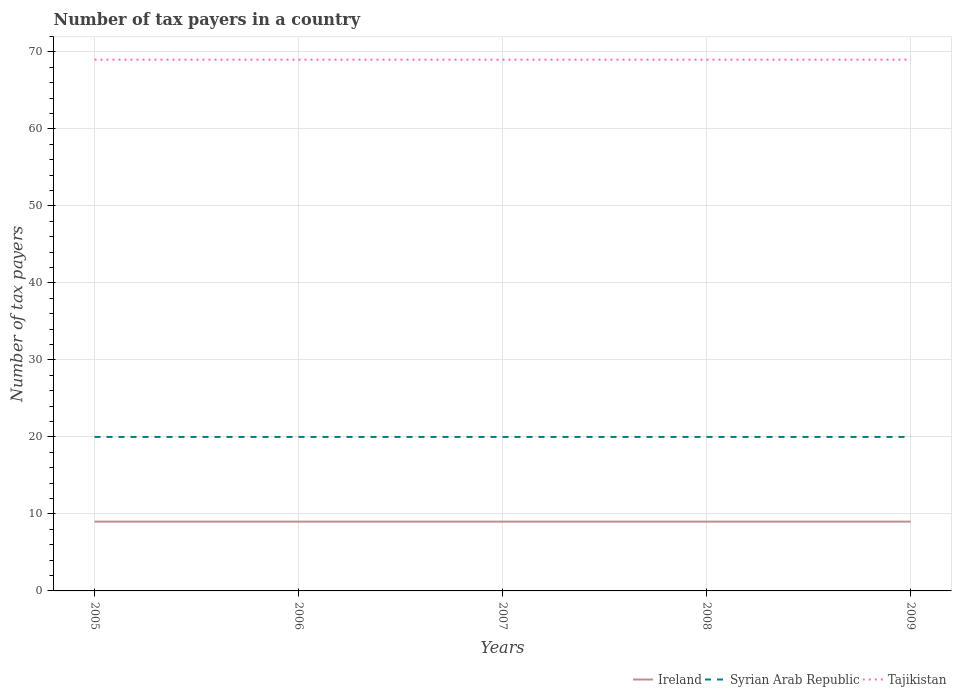How many different coloured lines are there?
Provide a short and direct response. 3. Across all years, what is the maximum number of tax payers in in Ireland?
Your answer should be compact. 9. What is the difference between the highest and the second highest number of tax payers in in Syrian Arab Republic?
Give a very brief answer. 0. What is the difference between the highest and the lowest number of tax payers in in Ireland?
Make the answer very short. 0. What is the difference between two consecutive major ticks on the Y-axis?
Keep it short and to the point. 10. Does the graph contain any zero values?
Provide a short and direct response. No. How many legend labels are there?
Make the answer very short. 3. How are the legend labels stacked?
Provide a short and direct response. Horizontal. What is the title of the graph?
Provide a short and direct response. Number of tax payers in a country. What is the label or title of the Y-axis?
Ensure brevity in your answer.  Number of tax payers. What is the Number of tax payers in Ireland in 2005?
Offer a very short reply. 9. What is the Number of tax payers of Syrian Arab Republic in 2005?
Give a very brief answer. 20. What is the Number of tax payers in Tajikistan in 2005?
Provide a short and direct response. 69. What is the Number of tax payers in Tajikistan in 2006?
Offer a very short reply. 69. What is the Number of tax payers in Ireland in 2007?
Give a very brief answer. 9. What is the Number of tax payers in Tajikistan in 2007?
Offer a very short reply. 69. What is the Number of tax payers of Syrian Arab Republic in 2008?
Provide a short and direct response. 20. What is the Number of tax payers of Tajikistan in 2008?
Offer a very short reply. 69. What is the Number of tax payers in Ireland in 2009?
Your answer should be very brief. 9. What is the Number of tax payers of Syrian Arab Republic in 2009?
Your response must be concise. 20. What is the Number of tax payers of Tajikistan in 2009?
Provide a succinct answer. 69. What is the total Number of tax payers of Tajikistan in the graph?
Your answer should be compact. 345. What is the difference between the Number of tax payers in Ireland in 2005 and that in 2006?
Offer a very short reply. 0. What is the difference between the Number of tax payers in Tajikistan in 2005 and that in 2006?
Make the answer very short. 0. What is the difference between the Number of tax payers of Tajikistan in 2005 and that in 2007?
Offer a very short reply. 0. What is the difference between the Number of tax payers in Syrian Arab Republic in 2005 and that in 2008?
Give a very brief answer. 0. What is the difference between the Number of tax payers in Tajikistan in 2005 and that in 2008?
Your answer should be very brief. 0. What is the difference between the Number of tax payers in Ireland in 2006 and that in 2007?
Give a very brief answer. 0. What is the difference between the Number of tax payers in Ireland in 2006 and that in 2008?
Your answer should be compact. 0. What is the difference between the Number of tax payers in Tajikistan in 2006 and that in 2008?
Your answer should be very brief. 0. What is the difference between the Number of tax payers in Ireland in 2006 and that in 2009?
Keep it short and to the point. 0. What is the difference between the Number of tax payers in Syrian Arab Republic in 2006 and that in 2009?
Offer a very short reply. 0. What is the difference between the Number of tax payers in Ireland in 2007 and that in 2008?
Your answer should be compact. 0. What is the difference between the Number of tax payers of Syrian Arab Republic in 2007 and that in 2008?
Keep it short and to the point. 0. What is the difference between the Number of tax payers of Tajikistan in 2007 and that in 2008?
Your answer should be very brief. 0. What is the difference between the Number of tax payers in Ireland in 2007 and that in 2009?
Offer a terse response. 0. What is the difference between the Number of tax payers of Syrian Arab Republic in 2007 and that in 2009?
Your response must be concise. 0. What is the difference between the Number of tax payers in Ireland in 2008 and that in 2009?
Offer a very short reply. 0. What is the difference between the Number of tax payers in Syrian Arab Republic in 2008 and that in 2009?
Your answer should be very brief. 0. What is the difference between the Number of tax payers in Tajikistan in 2008 and that in 2009?
Your answer should be compact. 0. What is the difference between the Number of tax payers in Ireland in 2005 and the Number of tax payers in Tajikistan in 2006?
Provide a succinct answer. -60. What is the difference between the Number of tax payers in Syrian Arab Republic in 2005 and the Number of tax payers in Tajikistan in 2006?
Give a very brief answer. -49. What is the difference between the Number of tax payers of Ireland in 2005 and the Number of tax payers of Syrian Arab Republic in 2007?
Ensure brevity in your answer.  -11. What is the difference between the Number of tax payers of Ireland in 2005 and the Number of tax payers of Tajikistan in 2007?
Your answer should be very brief. -60. What is the difference between the Number of tax payers in Syrian Arab Republic in 2005 and the Number of tax payers in Tajikistan in 2007?
Your answer should be compact. -49. What is the difference between the Number of tax payers of Ireland in 2005 and the Number of tax payers of Tajikistan in 2008?
Give a very brief answer. -60. What is the difference between the Number of tax payers in Syrian Arab Republic in 2005 and the Number of tax payers in Tajikistan in 2008?
Ensure brevity in your answer.  -49. What is the difference between the Number of tax payers in Ireland in 2005 and the Number of tax payers in Syrian Arab Republic in 2009?
Keep it short and to the point. -11. What is the difference between the Number of tax payers in Ireland in 2005 and the Number of tax payers in Tajikistan in 2009?
Ensure brevity in your answer.  -60. What is the difference between the Number of tax payers in Syrian Arab Republic in 2005 and the Number of tax payers in Tajikistan in 2009?
Your answer should be compact. -49. What is the difference between the Number of tax payers of Ireland in 2006 and the Number of tax payers of Tajikistan in 2007?
Offer a very short reply. -60. What is the difference between the Number of tax payers in Syrian Arab Republic in 2006 and the Number of tax payers in Tajikistan in 2007?
Provide a succinct answer. -49. What is the difference between the Number of tax payers of Ireland in 2006 and the Number of tax payers of Tajikistan in 2008?
Provide a short and direct response. -60. What is the difference between the Number of tax payers of Syrian Arab Republic in 2006 and the Number of tax payers of Tajikistan in 2008?
Your answer should be compact. -49. What is the difference between the Number of tax payers of Ireland in 2006 and the Number of tax payers of Syrian Arab Republic in 2009?
Your answer should be very brief. -11. What is the difference between the Number of tax payers in Ireland in 2006 and the Number of tax payers in Tajikistan in 2009?
Offer a terse response. -60. What is the difference between the Number of tax payers in Syrian Arab Republic in 2006 and the Number of tax payers in Tajikistan in 2009?
Give a very brief answer. -49. What is the difference between the Number of tax payers of Ireland in 2007 and the Number of tax payers of Tajikistan in 2008?
Provide a short and direct response. -60. What is the difference between the Number of tax payers in Syrian Arab Republic in 2007 and the Number of tax payers in Tajikistan in 2008?
Make the answer very short. -49. What is the difference between the Number of tax payers of Ireland in 2007 and the Number of tax payers of Syrian Arab Republic in 2009?
Offer a terse response. -11. What is the difference between the Number of tax payers of Ireland in 2007 and the Number of tax payers of Tajikistan in 2009?
Offer a terse response. -60. What is the difference between the Number of tax payers of Syrian Arab Republic in 2007 and the Number of tax payers of Tajikistan in 2009?
Provide a short and direct response. -49. What is the difference between the Number of tax payers of Ireland in 2008 and the Number of tax payers of Syrian Arab Republic in 2009?
Give a very brief answer. -11. What is the difference between the Number of tax payers of Ireland in 2008 and the Number of tax payers of Tajikistan in 2009?
Make the answer very short. -60. What is the difference between the Number of tax payers of Syrian Arab Republic in 2008 and the Number of tax payers of Tajikistan in 2009?
Provide a short and direct response. -49. What is the average Number of tax payers in Ireland per year?
Provide a short and direct response. 9. What is the average Number of tax payers in Syrian Arab Republic per year?
Provide a succinct answer. 20. In the year 2005, what is the difference between the Number of tax payers in Ireland and Number of tax payers in Tajikistan?
Make the answer very short. -60. In the year 2005, what is the difference between the Number of tax payers in Syrian Arab Republic and Number of tax payers in Tajikistan?
Provide a succinct answer. -49. In the year 2006, what is the difference between the Number of tax payers in Ireland and Number of tax payers in Syrian Arab Republic?
Offer a terse response. -11. In the year 2006, what is the difference between the Number of tax payers in Ireland and Number of tax payers in Tajikistan?
Provide a short and direct response. -60. In the year 2006, what is the difference between the Number of tax payers in Syrian Arab Republic and Number of tax payers in Tajikistan?
Your response must be concise. -49. In the year 2007, what is the difference between the Number of tax payers of Ireland and Number of tax payers of Tajikistan?
Ensure brevity in your answer.  -60. In the year 2007, what is the difference between the Number of tax payers in Syrian Arab Republic and Number of tax payers in Tajikistan?
Provide a succinct answer. -49. In the year 2008, what is the difference between the Number of tax payers of Ireland and Number of tax payers of Syrian Arab Republic?
Offer a terse response. -11. In the year 2008, what is the difference between the Number of tax payers in Ireland and Number of tax payers in Tajikistan?
Your response must be concise. -60. In the year 2008, what is the difference between the Number of tax payers of Syrian Arab Republic and Number of tax payers of Tajikistan?
Make the answer very short. -49. In the year 2009, what is the difference between the Number of tax payers in Ireland and Number of tax payers in Tajikistan?
Your answer should be compact. -60. In the year 2009, what is the difference between the Number of tax payers in Syrian Arab Republic and Number of tax payers in Tajikistan?
Provide a short and direct response. -49. What is the ratio of the Number of tax payers in Tajikistan in 2005 to that in 2006?
Give a very brief answer. 1. What is the ratio of the Number of tax payers of Ireland in 2005 to that in 2007?
Make the answer very short. 1. What is the ratio of the Number of tax payers in Syrian Arab Republic in 2005 to that in 2007?
Ensure brevity in your answer.  1. What is the ratio of the Number of tax payers of Tajikistan in 2005 to that in 2007?
Your response must be concise. 1. What is the ratio of the Number of tax payers of Ireland in 2005 to that in 2008?
Provide a succinct answer. 1. What is the ratio of the Number of tax payers in Tajikistan in 2005 to that in 2009?
Your response must be concise. 1. What is the ratio of the Number of tax payers of Ireland in 2006 to that in 2007?
Offer a terse response. 1. What is the ratio of the Number of tax payers of Syrian Arab Republic in 2006 to that in 2007?
Ensure brevity in your answer.  1. What is the ratio of the Number of tax payers in Tajikistan in 2006 to that in 2007?
Your response must be concise. 1. What is the ratio of the Number of tax payers in Ireland in 2006 to that in 2008?
Provide a short and direct response. 1. What is the ratio of the Number of tax payers of Syrian Arab Republic in 2006 to that in 2008?
Provide a succinct answer. 1. What is the ratio of the Number of tax payers in Tajikistan in 2006 to that in 2008?
Provide a short and direct response. 1. What is the ratio of the Number of tax payers in Syrian Arab Republic in 2006 to that in 2009?
Make the answer very short. 1. What is the ratio of the Number of tax payers in Ireland in 2007 to that in 2008?
Your answer should be compact. 1. What is the ratio of the Number of tax payers in Tajikistan in 2008 to that in 2009?
Give a very brief answer. 1. What is the difference between the highest and the second highest Number of tax payers of Ireland?
Your answer should be compact. 0. What is the difference between the highest and the second highest Number of tax payers of Tajikistan?
Ensure brevity in your answer.  0. What is the difference between the highest and the lowest Number of tax payers in Tajikistan?
Offer a very short reply. 0. 